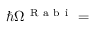Convert formula to latex. <formula><loc_0><loc_0><loc_500><loc_500>\hbar { \Omega } ^ { R a b i } =</formula> 